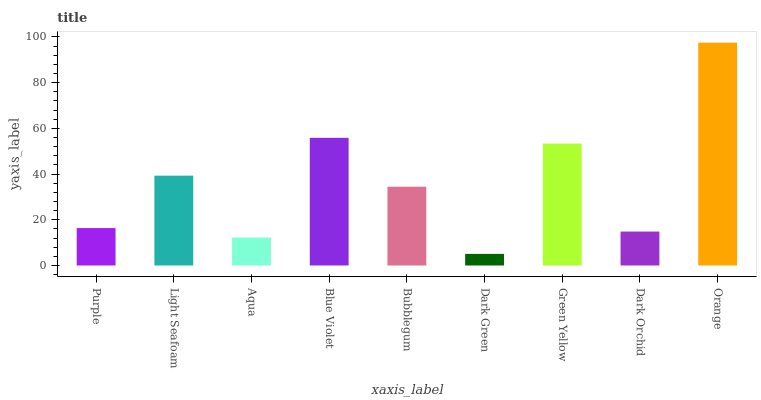Is Dark Green the minimum?
Answer yes or no. Yes. Is Orange the maximum?
Answer yes or no. Yes. Is Light Seafoam the minimum?
Answer yes or no. No. Is Light Seafoam the maximum?
Answer yes or no. No. Is Light Seafoam greater than Purple?
Answer yes or no. Yes. Is Purple less than Light Seafoam?
Answer yes or no. Yes. Is Purple greater than Light Seafoam?
Answer yes or no. No. Is Light Seafoam less than Purple?
Answer yes or no. No. Is Bubblegum the high median?
Answer yes or no. Yes. Is Bubblegum the low median?
Answer yes or no. Yes. Is Dark Green the high median?
Answer yes or no. No. Is Green Yellow the low median?
Answer yes or no. No. 